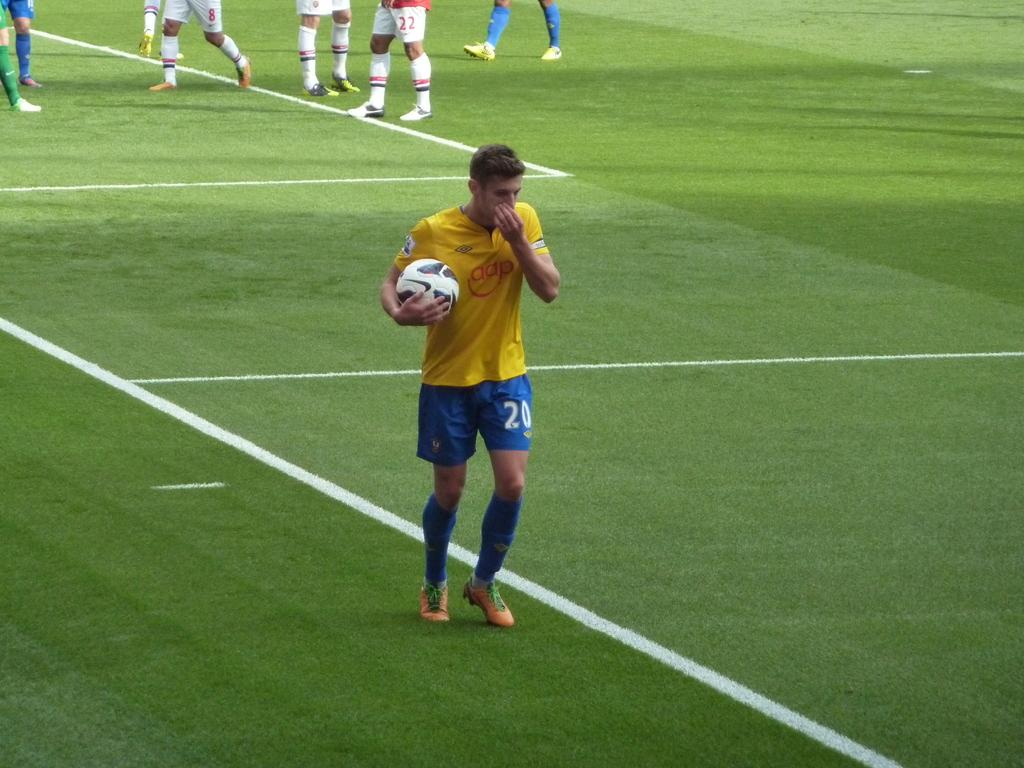Who is the main subject in the image? There is a man in the image. What is the man holding in the image? The man is holding a ball. What is the man doing in the image? The man is walking, as indicated by leg movement. Can you describe the surroundings in the image? There are other people standing in the distance. What type of history lesson is the man teaching in the image? There is no indication in the image that the man is teaching a history lesson, as the facts provided only mention that he is holding a ball and walking. 